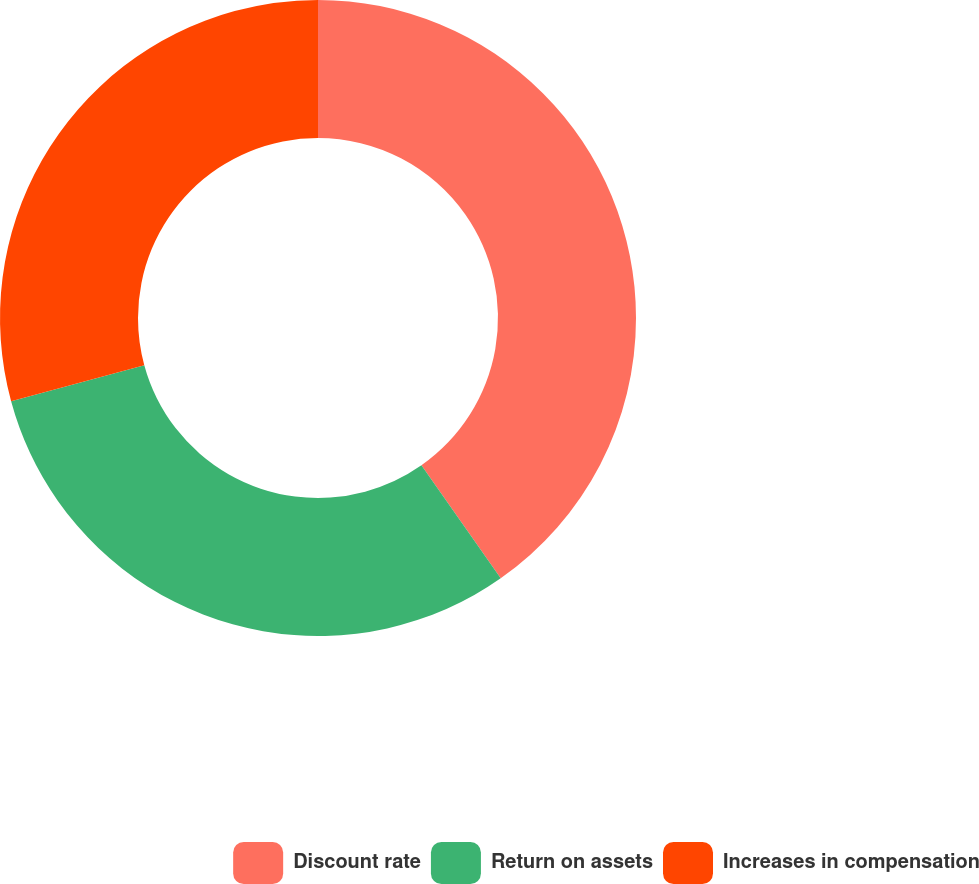Convert chart. <chart><loc_0><loc_0><loc_500><loc_500><pie_chart><fcel>Discount rate<fcel>Return on assets<fcel>Increases in compensation<nl><fcel>40.26%<fcel>30.52%<fcel>29.22%<nl></chart> 